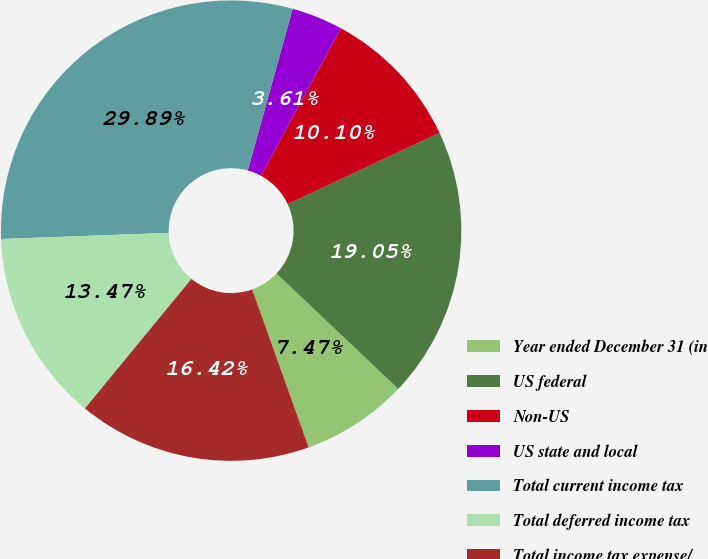Convert chart to OTSL. <chart><loc_0><loc_0><loc_500><loc_500><pie_chart><fcel>Year ended December 31 (in<fcel>US federal<fcel>Non-US<fcel>US state and local<fcel>Total current income tax<fcel>Total deferred income tax<fcel>Total income tax expense/<nl><fcel>7.47%<fcel>19.05%<fcel>10.1%<fcel>3.61%<fcel>29.89%<fcel>13.47%<fcel>16.42%<nl></chart> 